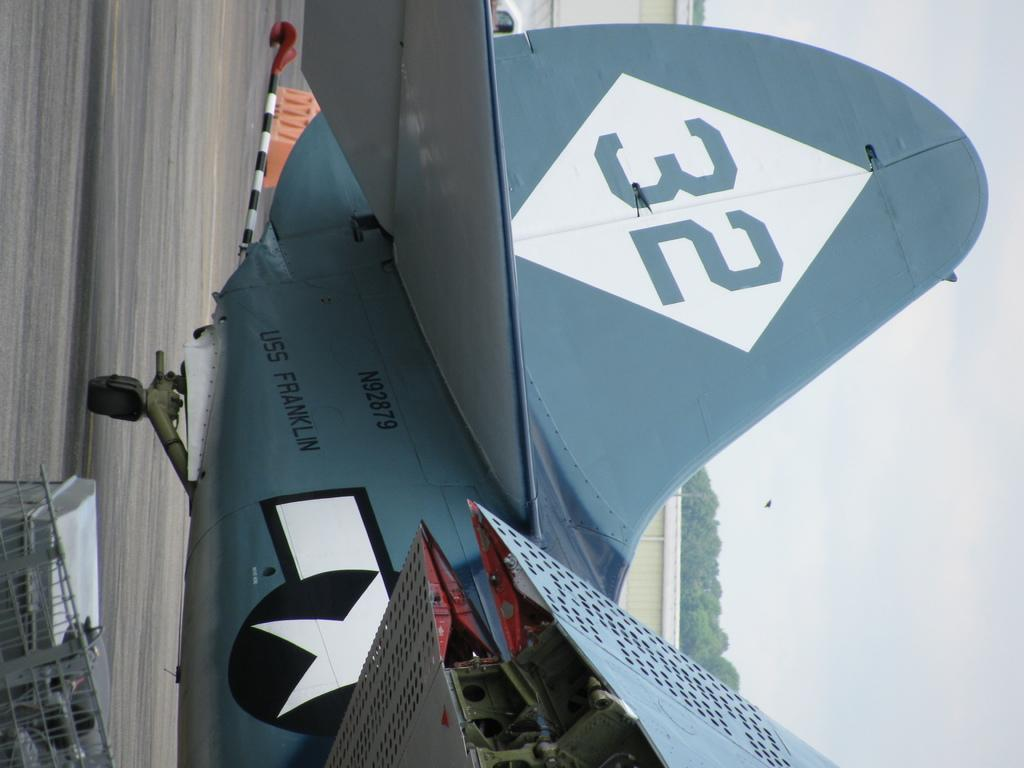<image>
Give a short and clear explanation of the subsequent image. the USS franklin is a blue plane with the number 32 on its tail 